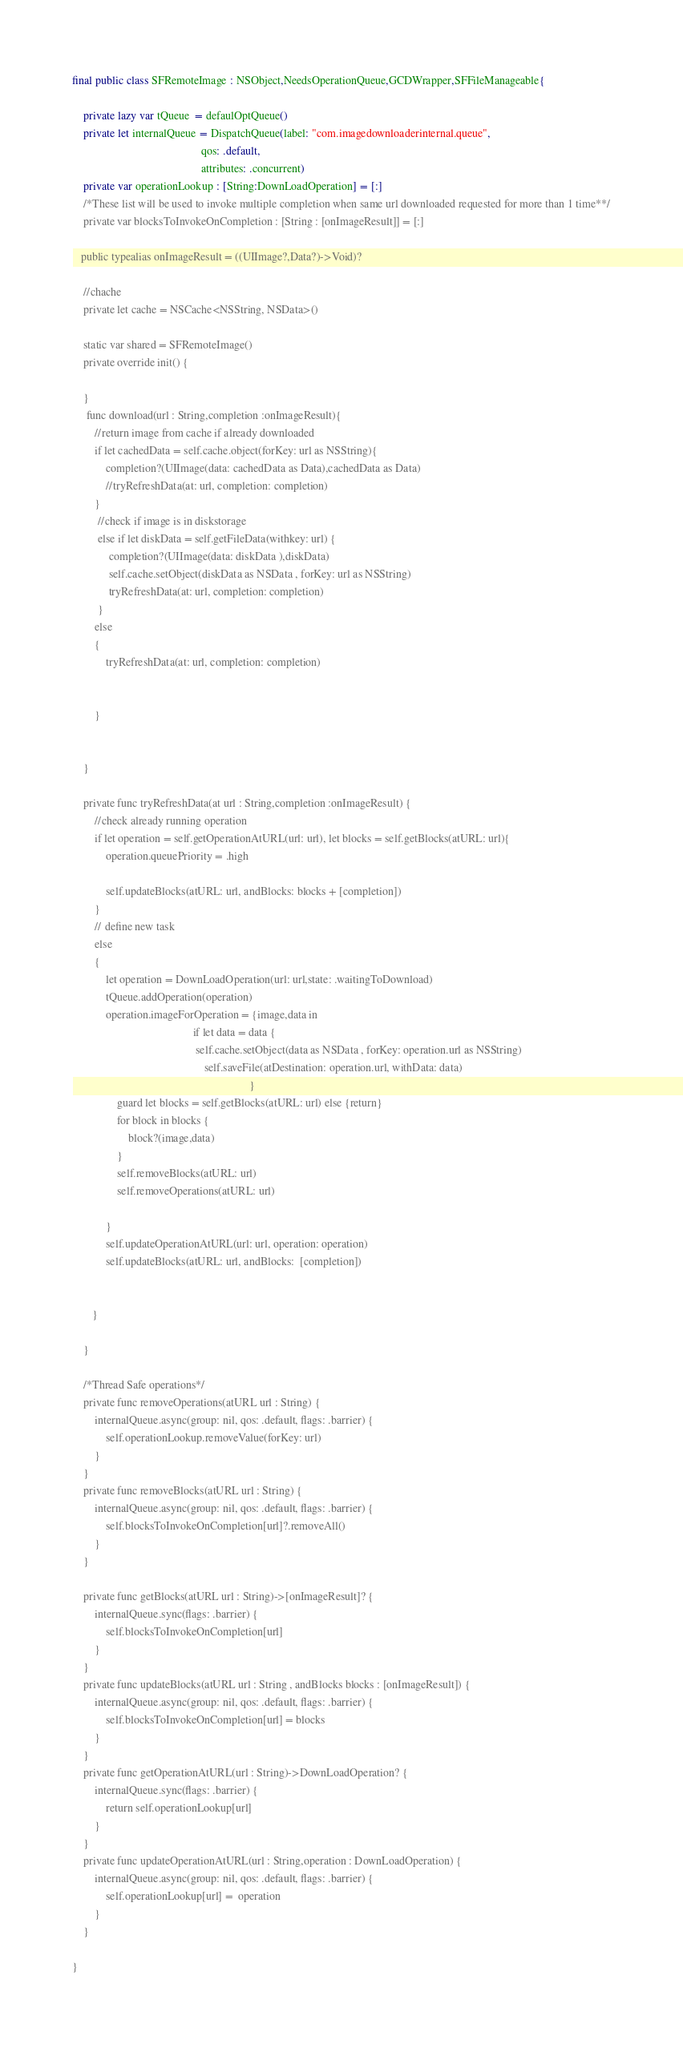Convert code to text. <code><loc_0><loc_0><loc_500><loc_500><_Swift_>
final public class SFRemoteImage : NSObject,NeedsOperationQueue,GCDWrapper,SFFileManageable{
    
    private lazy var tQueue  = defaulOptQueue()
    private let internalQueue = DispatchQueue(label: "com.imagedownloaderinternal.queue",
                                              qos: .default,
                                              attributes: .concurrent)
    private var operationLookup : [String:DownLoadOperation] = [:]
    /*These list will be used to invoke multiple completion when same url downloaded requested for more than 1 time**/
    private var blocksToInvokeOnCompletion : [String : [onImageResult]] = [:]
    
   public typealias onImageResult = ((UIImage?,Data?)->Void)?
    
    //chache
    private let cache = NSCache<NSString, NSData>()
    
    static var shared = SFRemoteImage()
    private override init() {
        
    }
     func download(url : String,completion :onImageResult){
        //return image from cache if already downloaded
        if let cachedData = self.cache.object(forKey: url as NSString){
            completion?(UIImage(data: cachedData as Data),cachedData as Data)
            //tryRefreshData(at: url, completion: completion)
        }
         //check if image is in diskstorage
         else if let diskData = self.getFileData(withkey: url) {
             completion?(UIImage(data: diskData ),diskData)
             self.cache.setObject(diskData as NSData , forKey: url as NSString)
             tryRefreshData(at: url, completion: completion)
         }
        else
        {
            tryRefreshData(at: url, completion: completion)
            
            
        }
        
        
    }
    
    private func tryRefreshData(at url : String,completion :onImageResult) {
        //check already running operation
        if let operation = self.getOperationAtURL(url: url), let blocks = self.getBlocks(atURL: url){
            operation.queuePriority = .high
            
            self.updateBlocks(atURL: url, andBlocks: blocks + [completion])
        }
        // define new task
        else
        {
            let operation = DownLoadOperation(url: url,state: .waitingToDownload)
            tQueue.addOperation(operation)
            operation.imageForOperation = {image,data in
                                           if let data = data {
                                            self.cache.setObject(data as NSData , forKey: operation.url as NSString)
                                               self.saveFile(atDestination: operation.url, withData: data)
                                                               }
                guard let blocks = self.getBlocks(atURL: url) else {return}
                for block in blocks {
                    block?(image,data)
                }
                self.removeBlocks(atURL: url)
                self.removeOperations(atURL: url)
                
            }
            self.updateOperationAtURL(url: url, operation: operation)
            self.updateBlocks(atURL: url, andBlocks:  [completion])
            
            
       }
        
    }
    
    /*Thread Safe operations*/
    private func removeOperations(atURL url : String) {
        internalQueue.async(group: nil, qos: .default, flags: .barrier) {
            self.operationLookup.removeValue(forKey: url)
        }
    }
    private func removeBlocks(atURL url : String) {
        internalQueue.async(group: nil, qos: .default, flags: .barrier) {
            self.blocksToInvokeOnCompletion[url]?.removeAll()
        }
    }
  
    private func getBlocks(atURL url : String)->[onImageResult]? {
        internalQueue.sync(flags: .barrier) {
            self.blocksToInvokeOnCompletion[url]
        }
    }
    private func updateBlocks(atURL url : String , andBlocks blocks : [onImageResult]) {
        internalQueue.async(group: nil, qos: .default, flags: .barrier) {
            self.blocksToInvokeOnCompletion[url] = blocks
        }
    }
    private func getOperationAtURL(url : String)->DownLoadOperation? {
        internalQueue.sync(flags: .barrier) {
            return self.operationLookup[url]
        }
    }
    private func updateOperationAtURL(url : String,operation : DownLoadOperation) {
        internalQueue.async(group: nil, qos: .default, flags: .barrier) {
            self.operationLookup[url] =  operation
        }
    }
  
}

</code> 